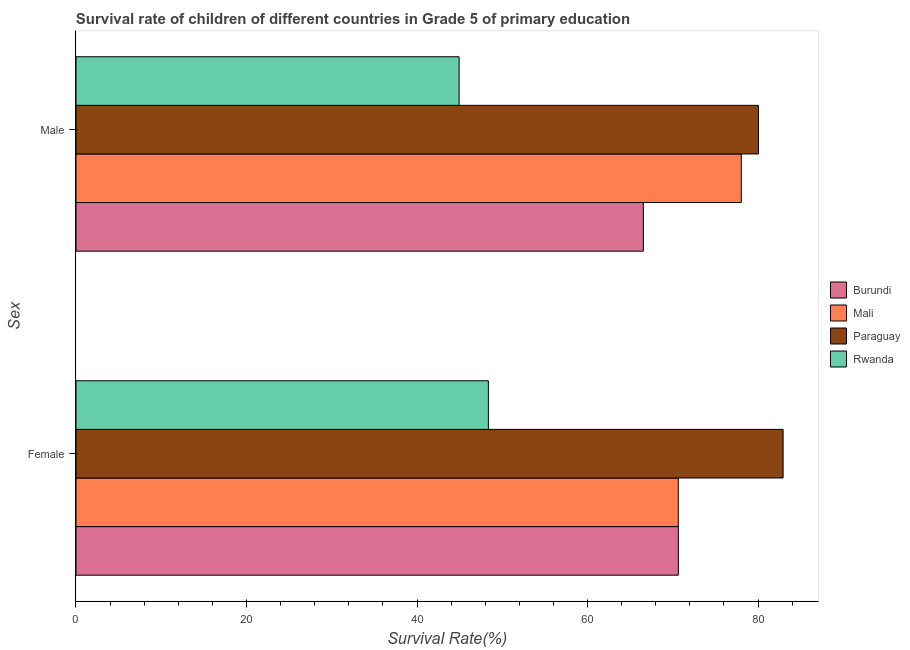Are the number of bars on each tick of the Y-axis equal?
Give a very brief answer. Yes. How many bars are there on the 2nd tick from the top?
Ensure brevity in your answer.  4. How many bars are there on the 1st tick from the bottom?
Offer a very short reply. 4. What is the survival rate of male students in primary education in Rwanda?
Keep it short and to the point. 44.94. Across all countries, what is the maximum survival rate of male students in primary education?
Your response must be concise. 80.05. Across all countries, what is the minimum survival rate of male students in primary education?
Offer a terse response. 44.94. In which country was the survival rate of male students in primary education maximum?
Keep it short and to the point. Paraguay. In which country was the survival rate of male students in primary education minimum?
Make the answer very short. Rwanda. What is the total survival rate of male students in primary education in the graph?
Offer a terse response. 269.58. What is the difference between the survival rate of male students in primary education in Burundi and that in Mali?
Make the answer very short. -11.49. What is the difference between the survival rate of female students in primary education in Rwanda and the survival rate of male students in primary education in Burundi?
Ensure brevity in your answer.  -18.18. What is the average survival rate of female students in primary education per country?
Provide a succinct answer. 68.15. What is the difference between the survival rate of male students in primary education and survival rate of female students in primary education in Paraguay?
Provide a short and direct response. -2.89. In how many countries, is the survival rate of female students in primary education greater than 16 %?
Your answer should be compact. 4. What is the ratio of the survival rate of female students in primary education in Burundi to that in Mali?
Your response must be concise. 1. Is the survival rate of male students in primary education in Rwanda less than that in Paraguay?
Provide a succinct answer. Yes. What does the 2nd bar from the top in Male represents?
Ensure brevity in your answer.  Paraguay. What does the 3rd bar from the bottom in Male represents?
Your answer should be compact. Paraguay. How many bars are there?
Provide a short and direct response. 8. How many countries are there in the graph?
Give a very brief answer. 4. Does the graph contain any zero values?
Give a very brief answer. No. Where does the legend appear in the graph?
Your answer should be compact. Center right. What is the title of the graph?
Your answer should be very brief. Survival rate of children of different countries in Grade 5 of primary education. Does "Lebanon" appear as one of the legend labels in the graph?
Keep it short and to the point. No. What is the label or title of the X-axis?
Make the answer very short. Survival Rate(%). What is the label or title of the Y-axis?
Your answer should be very brief. Sex. What is the Survival Rate(%) of Burundi in Female?
Your answer should be compact. 70.66. What is the Survival Rate(%) in Mali in Female?
Provide a short and direct response. 70.65. What is the Survival Rate(%) of Paraguay in Female?
Your answer should be compact. 82.94. What is the Survival Rate(%) in Rwanda in Female?
Make the answer very short. 48.37. What is the Survival Rate(%) in Burundi in Male?
Your answer should be compact. 66.55. What is the Survival Rate(%) of Mali in Male?
Your answer should be very brief. 78.04. What is the Survival Rate(%) of Paraguay in Male?
Your answer should be very brief. 80.05. What is the Survival Rate(%) in Rwanda in Male?
Your response must be concise. 44.94. Across all Sex, what is the maximum Survival Rate(%) of Burundi?
Offer a very short reply. 70.66. Across all Sex, what is the maximum Survival Rate(%) of Mali?
Keep it short and to the point. 78.04. Across all Sex, what is the maximum Survival Rate(%) of Paraguay?
Your response must be concise. 82.94. Across all Sex, what is the maximum Survival Rate(%) in Rwanda?
Your answer should be compact. 48.37. Across all Sex, what is the minimum Survival Rate(%) of Burundi?
Your response must be concise. 66.55. Across all Sex, what is the minimum Survival Rate(%) of Mali?
Give a very brief answer. 70.65. Across all Sex, what is the minimum Survival Rate(%) in Paraguay?
Offer a terse response. 80.05. Across all Sex, what is the minimum Survival Rate(%) in Rwanda?
Your response must be concise. 44.94. What is the total Survival Rate(%) in Burundi in the graph?
Keep it short and to the point. 137.2. What is the total Survival Rate(%) of Mali in the graph?
Provide a short and direct response. 148.69. What is the total Survival Rate(%) in Paraguay in the graph?
Your answer should be compact. 163. What is the total Survival Rate(%) of Rwanda in the graph?
Ensure brevity in your answer.  93.31. What is the difference between the Survival Rate(%) of Burundi in Female and that in Male?
Your answer should be very brief. 4.11. What is the difference between the Survival Rate(%) in Mali in Female and that in Male?
Keep it short and to the point. -7.39. What is the difference between the Survival Rate(%) in Paraguay in Female and that in Male?
Offer a very short reply. 2.89. What is the difference between the Survival Rate(%) in Rwanda in Female and that in Male?
Your answer should be compact. 3.43. What is the difference between the Survival Rate(%) of Burundi in Female and the Survival Rate(%) of Mali in Male?
Make the answer very short. -7.38. What is the difference between the Survival Rate(%) of Burundi in Female and the Survival Rate(%) of Paraguay in Male?
Keep it short and to the point. -9.4. What is the difference between the Survival Rate(%) in Burundi in Female and the Survival Rate(%) in Rwanda in Male?
Provide a succinct answer. 25.72. What is the difference between the Survival Rate(%) in Mali in Female and the Survival Rate(%) in Paraguay in Male?
Ensure brevity in your answer.  -9.41. What is the difference between the Survival Rate(%) of Mali in Female and the Survival Rate(%) of Rwanda in Male?
Your response must be concise. 25.71. What is the difference between the Survival Rate(%) of Paraguay in Female and the Survival Rate(%) of Rwanda in Male?
Keep it short and to the point. 38. What is the average Survival Rate(%) of Burundi per Sex?
Make the answer very short. 68.6. What is the average Survival Rate(%) of Mali per Sex?
Give a very brief answer. 74.34. What is the average Survival Rate(%) of Paraguay per Sex?
Keep it short and to the point. 81.5. What is the average Survival Rate(%) of Rwanda per Sex?
Make the answer very short. 46.66. What is the difference between the Survival Rate(%) of Burundi and Survival Rate(%) of Mali in Female?
Your response must be concise. 0.01. What is the difference between the Survival Rate(%) of Burundi and Survival Rate(%) of Paraguay in Female?
Offer a very short reply. -12.29. What is the difference between the Survival Rate(%) in Burundi and Survival Rate(%) in Rwanda in Female?
Your response must be concise. 22.28. What is the difference between the Survival Rate(%) in Mali and Survival Rate(%) in Paraguay in Female?
Offer a terse response. -12.3. What is the difference between the Survival Rate(%) in Mali and Survival Rate(%) in Rwanda in Female?
Provide a succinct answer. 22.28. What is the difference between the Survival Rate(%) in Paraguay and Survival Rate(%) in Rwanda in Female?
Your response must be concise. 34.57. What is the difference between the Survival Rate(%) of Burundi and Survival Rate(%) of Mali in Male?
Ensure brevity in your answer.  -11.49. What is the difference between the Survival Rate(%) of Burundi and Survival Rate(%) of Paraguay in Male?
Make the answer very short. -13.51. What is the difference between the Survival Rate(%) of Burundi and Survival Rate(%) of Rwanda in Male?
Give a very brief answer. 21.61. What is the difference between the Survival Rate(%) in Mali and Survival Rate(%) in Paraguay in Male?
Offer a very short reply. -2.02. What is the difference between the Survival Rate(%) of Mali and Survival Rate(%) of Rwanda in Male?
Provide a succinct answer. 33.1. What is the difference between the Survival Rate(%) of Paraguay and Survival Rate(%) of Rwanda in Male?
Provide a succinct answer. 35.12. What is the ratio of the Survival Rate(%) in Burundi in Female to that in Male?
Provide a succinct answer. 1.06. What is the ratio of the Survival Rate(%) of Mali in Female to that in Male?
Your answer should be very brief. 0.91. What is the ratio of the Survival Rate(%) in Paraguay in Female to that in Male?
Offer a very short reply. 1.04. What is the ratio of the Survival Rate(%) in Rwanda in Female to that in Male?
Your response must be concise. 1.08. What is the difference between the highest and the second highest Survival Rate(%) of Burundi?
Offer a terse response. 4.11. What is the difference between the highest and the second highest Survival Rate(%) of Mali?
Your answer should be very brief. 7.39. What is the difference between the highest and the second highest Survival Rate(%) of Paraguay?
Ensure brevity in your answer.  2.89. What is the difference between the highest and the second highest Survival Rate(%) in Rwanda?
Offer a very short reply. 3.43. What is the difference between the highest and the lowest Survival Rate(%) of Burundi?
Your answer should be compact. 4.11. What is the difference between the highest and the lowest Survival Rate(%) of Mali?
Offer a terse response. 7.39. What is the difference between the highest and the lowest Survival Rate(%) in Paraguay?
Provide a short and direct response. 2.89. What is the difference between the highest and the lowest Survival Rate(%) of Rwanda?
Your answer should be compact. 3.43. 